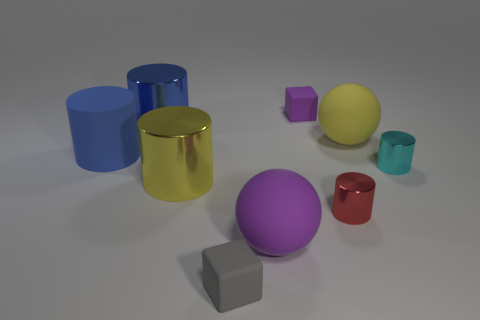Does the big purple object have the same material as the large blue thing that is behind the blue rubber cylinder?
Make the answer very short. No. What number of gray blocks are the same material as the small red cylinder?
Offer a very short reply. 0. There is a thing that is behind the blue metal thing; what shape is it?
Provide a short and direct response. Cube. Is the material of the tiny purple cube left of the yellow rubber thing the same as the blue thing that is in front of the yellow matte sphere?
Provide a succinct answer. Yes. Are there any small blue shiny objects that have the same shape as the small cyan metal object?
Give a very brief answer. No. What number of objects are either things that are on the left side of the small gray block or balls?
Your response must be concise. 5. Are there more metal objects behind the small cyan metallic thing than big yellow rubber things that are to the left of the small gray matte thing?
Offer a terse response. Yes. How many metallic objects are tiny red things or small green cylinders?
Ensure brevity in your answer.  1. What material is the other cylinder that is the same color as the large matte cylinder?
Offer a very short reply. Metal. Are there fewer rubber cubes behind the yellow rubber sphere than large yellow things on the left side of the big purple sphere?
Provide a succinct answer. No. 